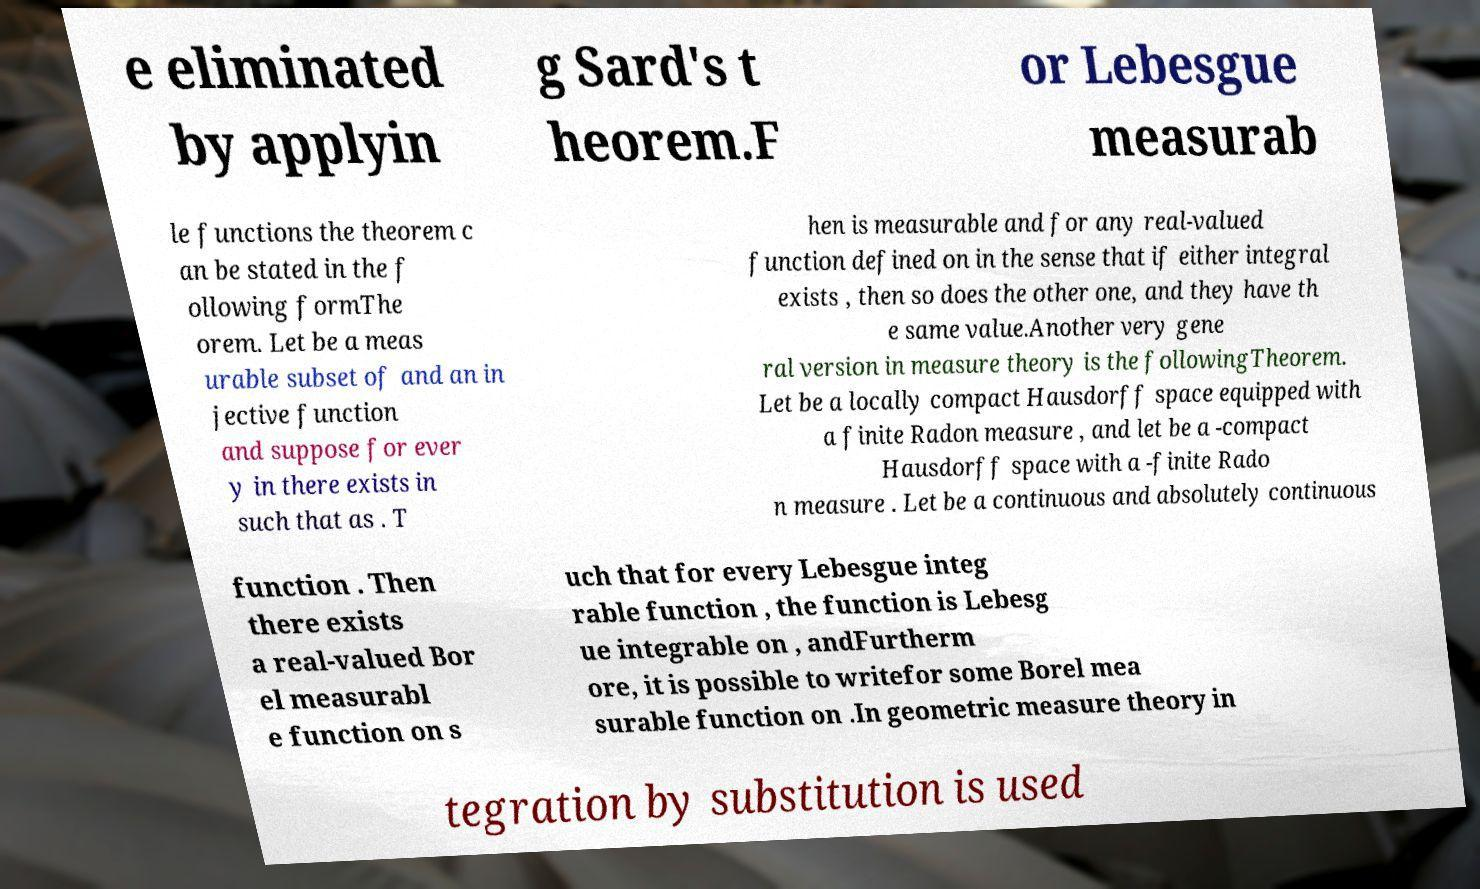I need the written content from this picture converted into text. Can you do that? e eliminated by applyin g Sard's t heorem.F or Lebesgue measurab le functions the theorem c an be stated in the f ollowing formThe orem. Let be a meas urable subset of and an in jective function and suppose for ever y in there exists in such that as . T hen is measurable and for any real-valued function defined on in the sense that if either integral exists , then so does the other one, and they have th e same value.Another very gene ral version in measure theory is the followingTheorem. Let be a locally compact Hausdorff space equipped with a finite Radon measure , and let be a -compact Hausdorff space with a -finite Rado n measure . Let be a continuous and absolutely continuous function . Then there exists a real-valued Bor el measurabl e function on s uch that for every Lebesgue integ rable function , the function is Lebesg ue integrable on , andFurtherm ore, it is possible to writefor some Borel mea surable function on .In geometric measure theory in tegration by substitution is used 